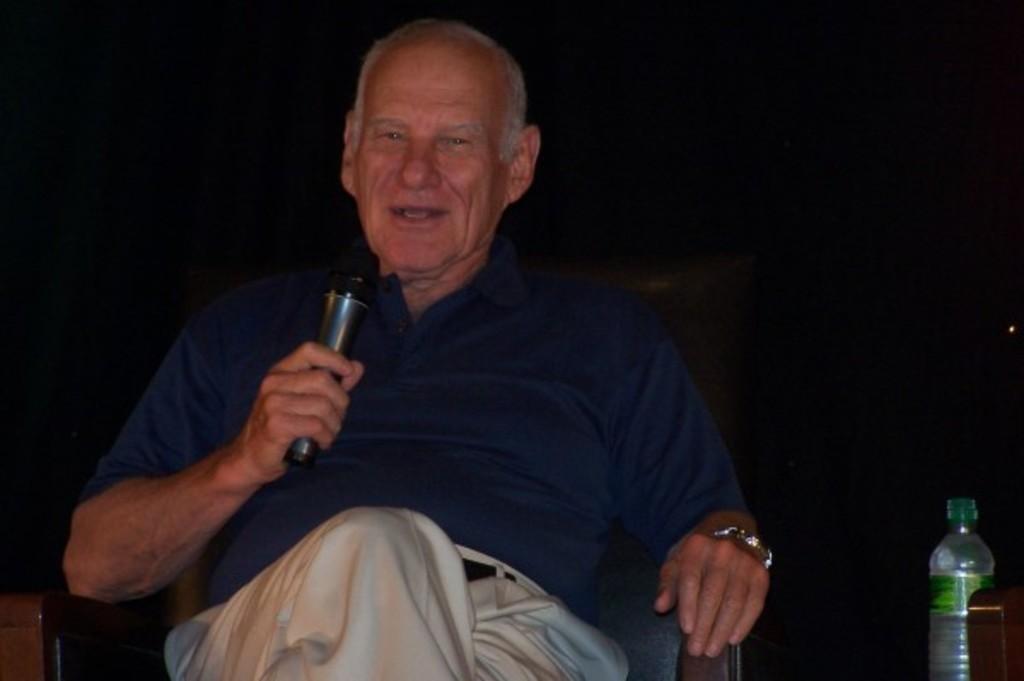Describe this image in one or two sentences. In this image there is a person sitting on a chair with blue t- shirt and white pant, he is holding a microphone and he is talking. There is a watch to his left hand and at the left of the picture there is a bottle. 